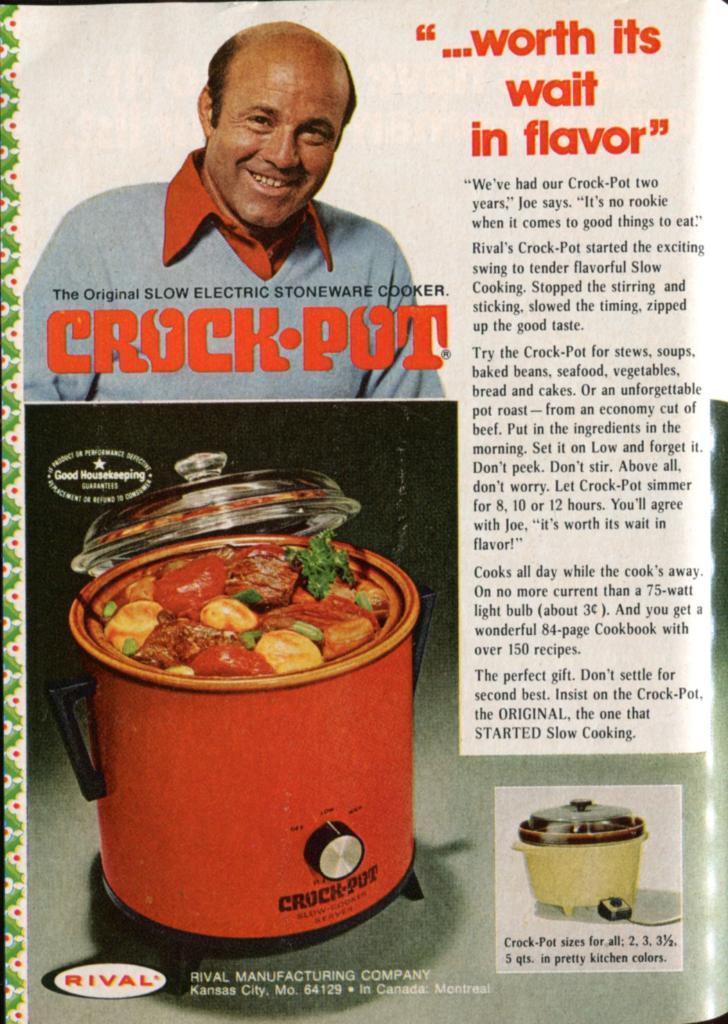Describe this image in one or two sentences. There is a picture of a person, an article and a cooker present on a magazine paper as we can see in the middle of this image. 